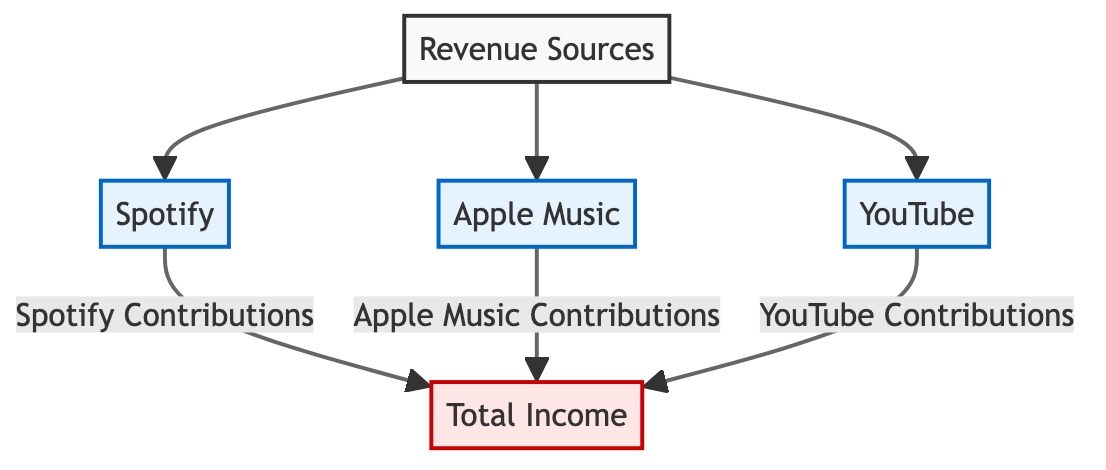What are the three revenue sources listed in the diagram? The diagram indicates three distinct revenue sources: Spotify, Apple Music, and YouTube. Each source is connected to the overall income node, indicating their contributions.
Answer: Spotify, Apple Music, YouTube How many platforms contribute to the total income? The diagram shows three platforms: Spotify, Apple Music, and YouTube, all of which contribute to the total income. Therefore, the total number of contributing platforms is three.
Answer: 3 Which platform's contribution is directly linked to the total income? Each platform (Spotify, Apple Music, YouTube) has a direct connection that flows into the total income node, indicating their individual contributions. All three platforms contribute directly.
Answer: All three What is the main node in this diagram? The main node in the diagram is Total Income. It represents the culmination of contributions from the various revenue sources, making it the focal point of the analysis.
Answer: Total Income Which platform is depicted first in the revenue sources hierarchy? Spotify is depicted first in the hierarchy of revenue sources, as it appears at the top of the flow leading to the total income node, followed by Apple Music and YouTube.
Answer: Spotify What type of relationship exists between the revenue sources and total income? The relationship depicted in the diagram is a contributing relationship, where each revenue source (Spotify, Apple Music, and YouTube) contributes to the total income. This signifies that the total income depends on these sources.
Answer: Contributing Is there a visual distinction for revenue source platforms? Yes, the revenue source platforms (Spotify, Apple Music, YouTube) are visually distinct, with a specific color fill (light blue) and stroke, allowing viewers to easily identify them compared to the total income node.
Answer: Yes How does the diagram visually categorize the nodes? The diagram categorizes the nodes into three classes: the default class (for Revenue Sources), the platform class (for Spotify, Apple Music, YouTube), and the total class (for Total Income), each with distinct colors and border styles for clarity.
Answer: Three classes 